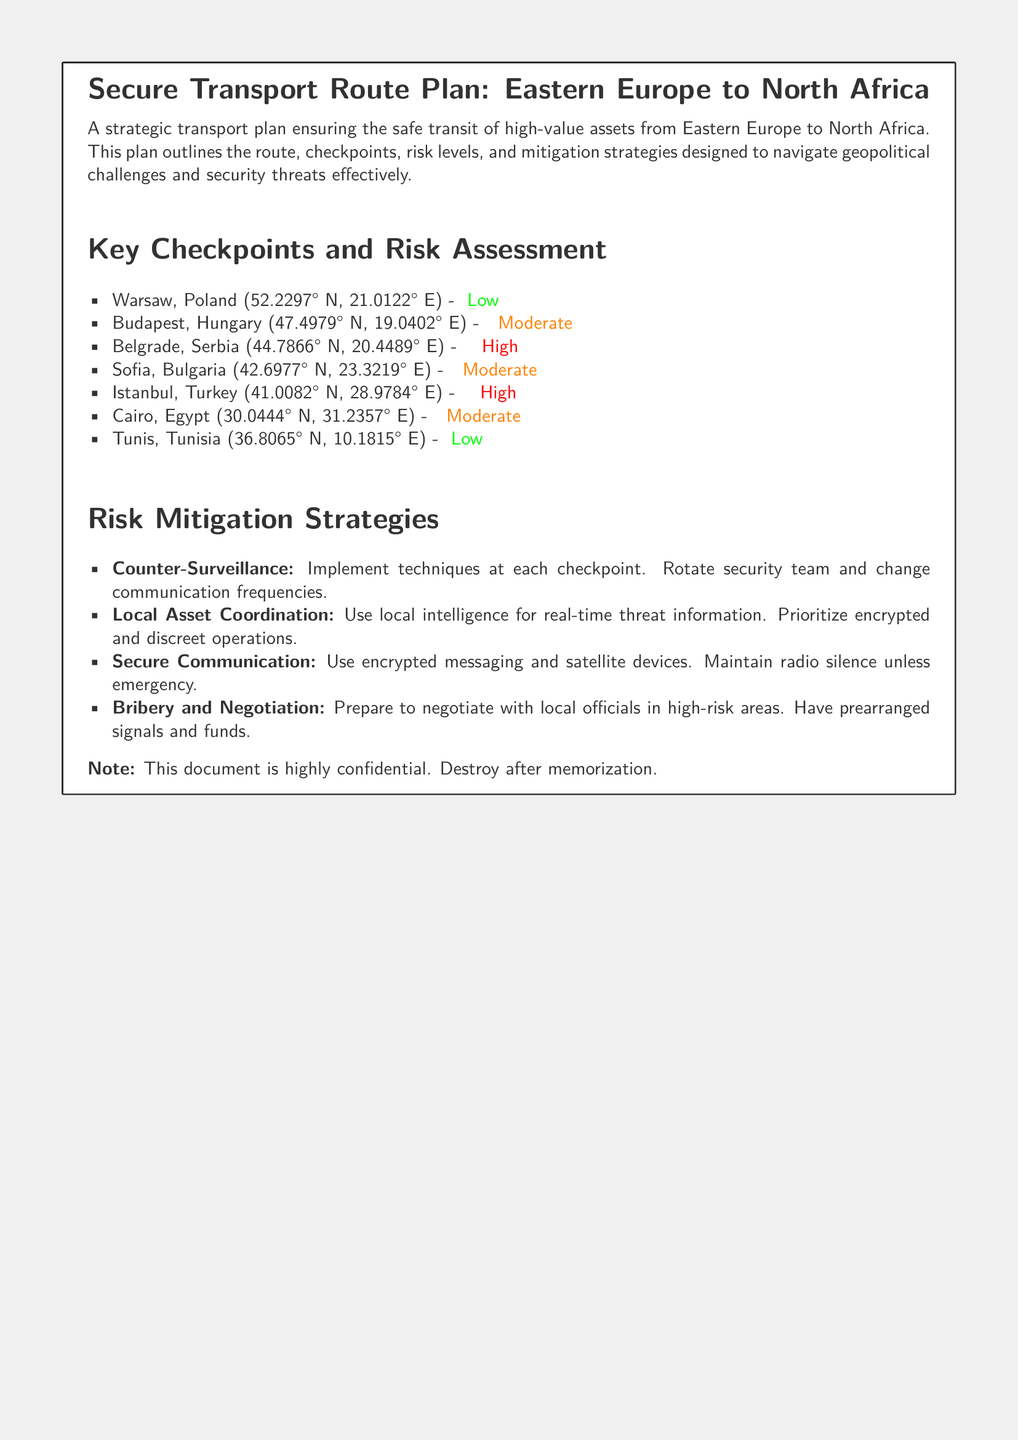What is the starting location of the transport route? The starting location is indicated as Warsaw, Poland in the document.
Answer: Warsaw, Poland What is the risk level for Belgrade, Serbia? The document specifies the risk level for Belgrade, Serbia as High.
Answer: High What mitigation strategy involves local intelligence? The document refers to Local Asset Coordination as a strategy involving local intelligence.
Answer: Local Asset Coordination What is the risk level for Tunis, Tunisia? The risk level for Tunis, Tunisia is stated as Low in the document.
Answer: Low How many checkpoints are listed in the plan? The plan includes a total of seven checkpoints as detailed in the document.
Answer: Seven What is the geographical coordinate format used in the document? The document uses a format including latitude and longitude for geographical coordinates.
Answer: Latitude and longitude What is the risk level for Cairo, Egypt? The document indicates the risk level for Cairo, Egypt as Moderate.
Answer: Moderate What strategy suggests changing communication frequencies? The document mentions Counter-Surveillance as the strategy that suggests changing communication frequencies.
Answer: Counter-Surveillance 